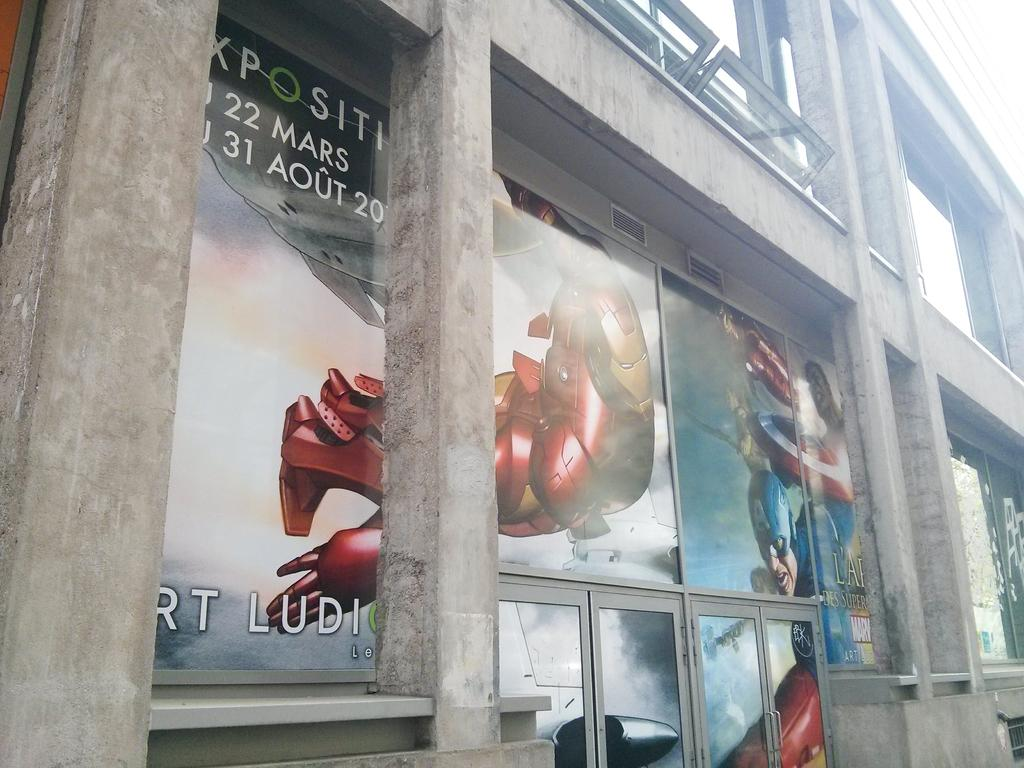What is the main structure visible in the image? There is a building in the image. What is unique about the building's appearance? The building has animated posters on it. What decision does the building make in the image? The building does not make decisions, as it is an inanimate object. How many planes are flying over the building in the image? There is no information about planes in the image, so we cannot determine if any are present. 